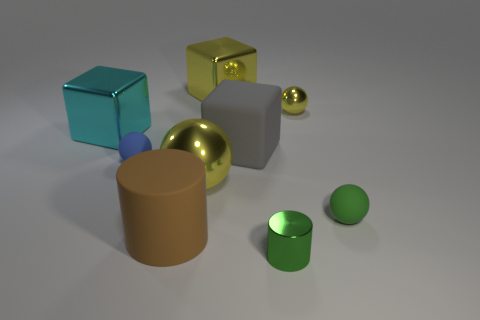Subtract all small yellow balls. How many balls are left? 3 Subtract all green cylinders. How many cylinders are left? 1 Subtract all spheres. How many objects are left? 5 Subtract 1 cubes. How many cubes are left? 2 Subtract all red balls. Subtract all blue cylinders. How many balls are left? 4 Subtract all blue balls. How many gray cylinders are left? 0 Subtract all brown objects. Subtract all gray matte things. How many objects are left? 7 Add 7 large rubber cylinders. How many large rubber cylinders are left? 8 Add 7 gray matte cubes. How many gray matte cubes exist? 8 Subtract 0 yellow cylinders. How many objects are left? 9 